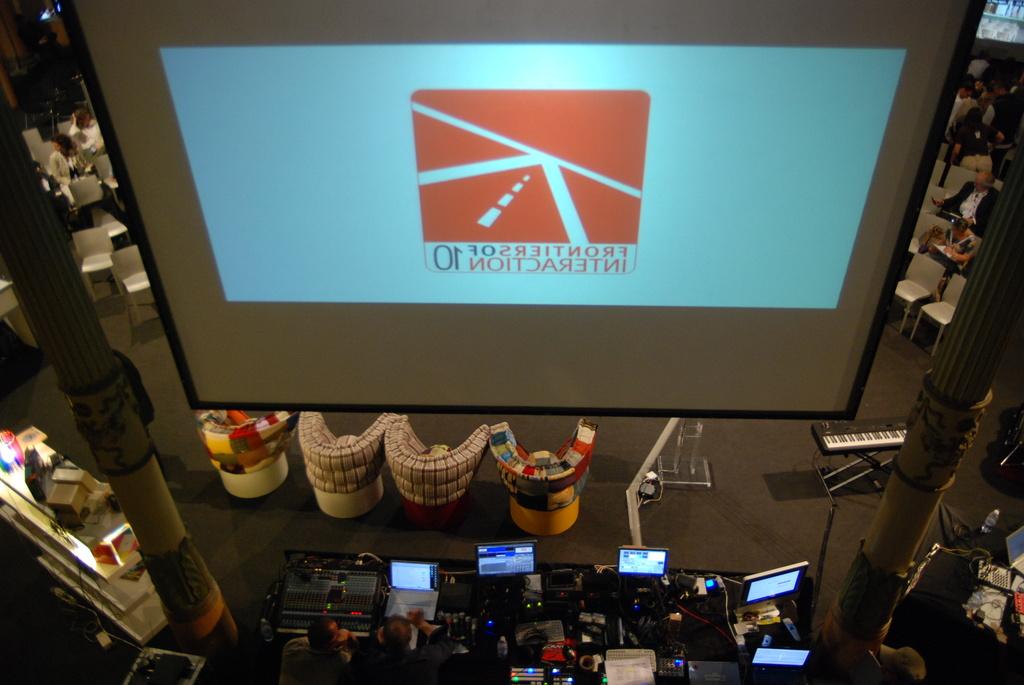Frontiers of what?
Your answer should be very brief. Interaction. What word is below frontier?
Keep it short and to the point. Interaction. 